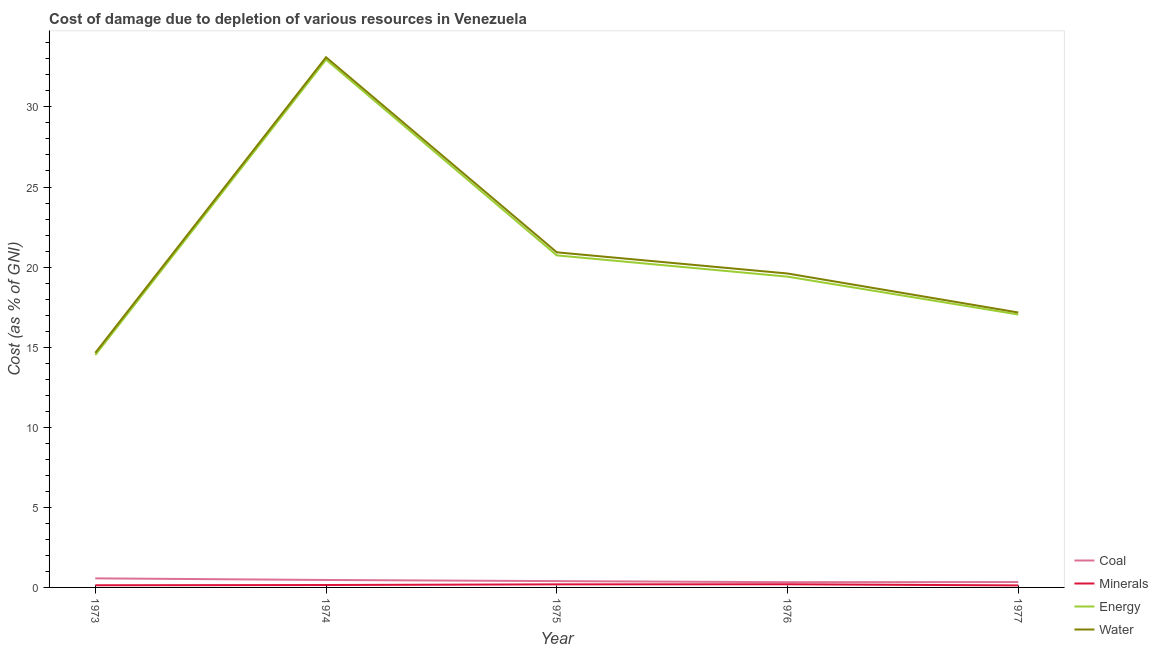Does the line corresponding to cost of damage due to depletion of minerals intersect with the line corresponding to cost of damage due to depletion of water?
Your answer should be compact. No. Is the number of lines equal to the number of legend labels?
Give a very brief answer. Yes. What is the cost of damage due to depletion of minerals in 1977?
Your response must be concise. 0.13. Across all years, what is the maximum cost of damage due to depletion of minerals?
Your response must be concise. 0.2. Across all years, what is the minimum cost of damage due to depletion of minerals?
Provide a succinct answer. 0.13. In which year was the cost of damage due to depletion of coal maximum?
Offer a terse response. 1973. What is the total cost of damage due to depletion of coal in the graph?
Ensure brevity in your answer.  2.09. What is the difference between the cost of damage due to depletion of energy in 1973 and that in 1977?
Your answer should be very brief. -2.53. What is the difference between the cost of damage due to depletion of minerals in 1973 and the cost of damage due to depletion of energy in 1974?
Provide a short and direct response. -32.82. What is the average cost of damage due to depletion of coal per year?
Offer a terse response. 0.42. In the year 1974, what is the difference between the cost of damage due to depletion of energy and cost of damage due to depletion of water?
Keep it short and to the point. -0.15. In how many years, is the cost of damage due to depletion of water greater than 26 %?
Your answer should be very brief. 1. What is the ratio of the cost of damage due to depletion of minerals in 1976 to that in 1977?
Keep it short and to the point. 1.56. Is the cost of damage due to depletion of energy in 1974 less than that in 1976?
Your answer should be compact. No. Is the difference between the cost of damage due to depletion of coal in 1974 and 1977 greater than the difference between the cost of damage due to depletion of minerals in 1974 and 1977?
Make the answer very short. Yes. What is the difference between the highest and the second highest cost of damage due to depletion of water?
Give a very brief answer. 12.18. What is the difference between the highest and the lowest cost of damage due to depletion of water?
Keep it short and to the point. 18.46. Is the sum of the cost of damage due to depletion of energy in 1974 and 1976 greater than the maximum cost of damage due to depletion of coal across all years?
Keep it short and to the point. Yes. Is it the case that in every year, the sum of the cost of damage due to depletion of energy and cost of damage due to depletion of minerals is greater than the sum of cost of damage due to depletion of water and cost of damage due to depletion of coal?
Provide a succinct answer. Yes. Is it the case that in every year, the sum of the cost of damage due to depletion of coal and cost of damage due to depletion of minerals is greater than the cost of damage due to depletion of energy?
Keep it short and to the point. No. Does the cost of damage due to depletion of water monotonically increase over the years?
Offer a very short reply. No. Is the cost of damage due to depletion of minerals strictly less than the cost of damage due to depletion of water over the years?
Provide a short and direct response. Yes. How many lines are there?
Keep it short and to the point. 4. Does the graph contain grids?
Provide a short and direct response. No. How many legend labels are there?
Give a very brief answer. 4. How are the legend labels stacked?
Your answer should be compact. Vertical. What is the title of the graph?
Give a very brief answer. Cost of damage due to depletion of various resources in Venezuela . What is the label or title of the X-axis?
Your answer should be very brief. Year. What is the label or title of the Y-axis?
Give a very brief answer. Cost (as % of GNI). What is the Cost (as % of GNI) of Coal in 1973?
Offer a terse response. 0.57. What is the Cost (as % of GNI) in Minerals in 1973?
Provide a succinct answer. 0.14. What is the Cost (as % of GNI) in Energy in 1973?
Provide a short and direct response. 14.51. What is the Cost (as % of GNI) of Water in 1973?
Provide a succinct answer. 14.65. What is the Cost (as % of GNI) of Coal in 1974?
Keep it short and to the point. 0.47. What is the Cost (as % of GNI) in Minerals in 1974?
Your answer should be very brief. 0.15. What is the Cost (as % of GNI) of Energy in 1974?
Your answer should be very brief. 32.95. What is the Cost (as % of GNI) in Water in 1974?
Keep it short and to the point. 33.1. What is the Cost (as % of GNI) of Coal in 1975?
Provide a succinct answer. 0.39. What is the Cost (as % of GNI) in Minerals in 1975?
Provide a succinct answer. 0.19. What is the Cost (as % of GNI) in Energy in 1975?
Make the answer very short. 20.73. What is the Cost (as % of GNI) of Water in 1975?
Ensure brevity in your answer.  20.92. What is the Cost (as % of GNI) in Coal in 1976?
Your response must be concise. 0.33. What is the Cost (as % of GNI) in Minerals in 1976?
Provide a succinct answer. 0.2. What is the Cost (as % of GNI) of Energy in 1976?
Give a very brief answer. 19.4. What is the Cost (as % of GNI) of Water in 1976?
Your response must be concise. 19.6. What is the Cost (as % of GNI) in Coal in 1977?
Provide a succinct answer. 0.34. What is the Cost (as % of GNI) of Minerals in 1977?
Ensure brevity in your answer.  0.13. What is the Cost (as % of GNI) in Energy in 1977?
Your response must be concise. 17.04. What is the Cost (as % of GNI) of Water in 1977?
Ensure brevity in your answer.  17.17. Across all years, what is the maximum Cost (as % of GNI) of Coal?
Your answer should be compact. 0.57. Across all years, what is the maximum Cost (as % of GNI) of Minerals?
Ensure brevity in your answer.  0.2. Across all years, what is the maximum Cost (as % of GNI) of Energy?
Your response must be concise. 32.95. Across all years, what is the maximum Cost (as % of GNI) of Water?
Keep it short and to the point. 33.1. Across all years, what is the minimum Cost (as % of GNI) of Coal?
Provide a succinct answer. 0.33. Across all years, what is the minimum Cost (as % of GNI) of Minerals?
Provide a short and direct response. 0.13. Across all years, what is the minimum Cost (as % of GNI) in Energy?
Offer a terse response. 14.51. Across all years, what is the minimum Cost (as % of GNI) of Water?
Ensure brevity in your answer.  14.65. What is the total Cost (as % of GNI) of Coal in the graph?
Your response must be concise. 2.09. What is the total Cost (as % of GNI) of Minerals in the graph?
Offer a very short reply. 0.8. What is the total Cost (as % of GNI) in Energy in the graph?
Your answer should be very brief. 104.63. What is the total Cost (as % of GNI) of Water in the graph?
Offer a terse response. 105.44. What is the difference between the Cost (as % of GNI) in Coal in 1973 and that in 1974?
Keep it short and to the point. 0.1. What is the difference between the Cost (as % of GNI) of Minerals in 1973 and that in 1974?
Offer a very short reply. -0.01. What is the difference between the Cost (as % of GNI) of Energy in 1973 and that in 1974?
Ensure brevity in your answer.  -18.44. What is the difference between the Cost (as % of GNI) in Water in 1973 and that in 1974?
Your answer should be compact. -18.46. What is the difference between the Cost (as % of GNI) of Coal in 1973 and that in 1975?
Your response must be concise. 0.17. What is the difference between the Cost (as % of GNI) in Minerals in 1973 and that in 1975?
Ensure brevity in your answer.  -0.06. What is the difference between the Cost (as % of GNI) in Energy in 1973 and that in 1975?
Make the answer very short. -6.22. What is the difference between the Cost (as % of GNI) of Water in 1973 and that in 1975?
Ensure brevity in your answer.  -6.28. What is the difference between the Cost (as % of GNI) in Coal in 1973 and that in 1976?
Ensure brevity in your answer.  0.24. What is the difference between the Cost (as % of GNI) of Minerals in 1973 and that in 1976?
Offer a very short reply. -0.06. What is the difference between the Cost (as % of GNI) in Energy in 1973 and that in 1976?
Your answer should be compact. -4.89. What is the difference between the Cost (as % of GNI) of Water in 1973 and that in 1976?
Your response must be concise. -4.95. What is the difference between the Cost (as % of GNI) in Coal in 1973 and that in 1977?
Provide a short and direct response. 0.23. What is the difference between the Cost (as % of GNI) in Minerals in 1973 and that in 1977?
Your answer should be compact. 0.01. What is the difference between the Cost (as % of GNI) in Energy in 1973 and that in 1977?
Provide a succinct answer. -2.53. What is the difference between the Cost (as % of GNI) of Water in 1973 and that in 1977?
Ensure brevity in your answer.  -2.52. What is the difference between the Cost (as % of GNI) in Coal in 1974 and that in 1975?
Make the answer very short. 0.07. What is the difference between the Cost (as % of GNI) in Minerals in 1974 and that in 1975?
Ensure brevity in your answer.  -0.04. What is the difference between the Cost (as % of GNI) in Energy in 1974 and that in 1975?
Give a very brief answer. 12.22. What is the difference between the Cost (as % of GNI) of Water in 1974 and that in 1975?
Provide a short and direct response. 12.18. What is the difference between the Cost (as % of GNI) in Coal in 1974 and that in 1976?
Provide a short and direct response. 0.14. What is the difference between the Cost (as % of GNI) in Minerals in 1974 and that in 1976?
Your response must be concise. -0.05. What is the difference between the Cost (as % of GNI) in Energy in 1974 and that in 1976?
Give a very brief answer. 13.55. What is the difference between the Cost (as % of GNI) of Water in 1974 and that in 1976?
Your response must be concise. 13.5. What is the difference between the Cost (as % of GNI) in Coal in 1974 and that in 1977?
Ensure brevity in your answer.  0.13. What is the difference between the Cost (as % of GNI) of Minerals in 1974 and that in 1977?
Offer a terse response. 0.02. What is the difference between the Cost (as % of GNI) in Energy in 1974 and that in 1977?
Your answer should be compact. 15.91. What is the difference between the Cost (as % of GNI) in Water in 1974 and that in 1977?
Your answer should be compact. 15.94. What is the difference between the Cost (as % of GNI) in Coal in 1975 and that in 1976?
Provide a succinct answer. 0.07. What is the difference between the Cost (as % of GNI) in Minerals in 1975 and that in 1976?
Make the answer very short. -0.01. What is the difference between the Cost (as % of GNI) in Energy in 1975 and that in 1976?
Keep it short and to the point. 1.33. What is the difference between the Cost (as % of GNI) in Water in 1975 and that in 1976?
Your answer should be very brief. 1.32. What is the difference between the Cost (as % of GNI) of Coal in 1975 and that in 1977?
Make the answer very short. 0.06. What is the difference between the Cost (as % of GNI) in Minerals in 1975 and that in 1977?
Keep it short and to the point. 0.06. What is the difference between the Cost (as % of GNI) of Energy in 1975 and that in 1977?
Ensure brevity in your answer.  3.69. What is the difference between the Cost (as % of GNI) of Water in 1975 and that in 1977?
Your answer should be compact. 3.76. What is the difference between the Cost (as % of GNI) of Coal in 1976 and that in 1977?
Offer a terse response. -0.01. What is the difference between the Cost (as % of GNI) of Minerals in 1976 and that in 1977?
Provide a short and direct response. 0.07. What is the difference between the Cost (as % of GNI) in Energy in 1976 and that in 1977?
Provide a succinct answer. 2.36. What is the difference between the Cost (as % of GNI) of Water in 1976 and that in 1977?
Your answer should be very brief. 2.43. What is the difference between the Cost (as % of GNI) in Coal in 1973 and the Cost (as % of GNI) in Minerals in 1974?
Offer a very short reply. 0.42. What is the difference between the Cost (as % of GNI) in Coal in 1973 and the Cost (as % of GNI) in Energy in 1974?
Provide a short and direct response. -32.38. What is the difference between the Cost (as % of GNI) in Coal in 1973 and the Cost (as % of GNI) in Water in 1974?
Make the answer very short. -32.54. What is the difference between the Cost (as % of GNI) in Minerals in 1973 and the Cost (as % of GNI) in Energy in 1974?
Give a very brief answer. -32.82. What is the difference between the Cost (as % of GNI) of Minerals in 1973 and the Cost (as % of GNI) of Water in 1974?
Provide a succinct answer. -32.97. What is the difference between the Cost (as % of GNI) in Energy in 1973 and the Cost (as % of GNI) in Water in 1974?
Provide a short and direct response. -18.59. What is the difference between the Cost (as % of GNI) of Coal in 1973 and the Cost (as % of GNI) of Minerals in 1975?
Offer a very short reply. 0.38. What is the difference between the Cost (as % of GNI) in Coal in 1973 and the Cost (as % of GNI) in Energy in 1975?
Ensure brevity in your answer.  -20.16. What is the difference between the Cost (as % of GNI) of Coal in 1973 and the Cost (as % of GNI) of Water in 1975?
Give a very brief answer. -20.36. What is the difference between the Cost (as % of GNI) of Minerals in 1973 and the Cost (as % of GNI) of Energy in 1975?
Offer a terse response. -20.59. What is the difference between the Cost (as % of GNI) in Minerals in 1973 and the Cost (as % of GNI) in Water in 1975?
Give a very brief answer. -20.79. What is the difference between the Cost (as % of GNI) in Energy in 1973 and the Cost (as % of GNI) in Water in 1975?
Offer a very short reply. -6.41. What is the difference between the Cost (as % of GNI) in Coal in 1973 and the Cost (as % of GNI) in Minerals in 1976?
Give a very brief answer. 0.37. What is the difference between the Cost (as % of GNI) of Coal in 1973 and the Cost (as % of GNI) of Energy in 1976?
Provide a short and direct response. -18.84. What is the difference between the Cost (as % of GNI) of Coal in 1973 and the Cost (as % of GNI) of Water in 1976?
Offer a terse response. -19.03. What is the difference between the Cost (as % of GNI) of Minerals in 1973 and the Cost (as % of GNI) of Energy in 1976?
Your response must be concise. -19.27. What is the difference between the Cost (as % of GNI) of Minerals in 1973 and the Cost (as % of GNI) of Water in 1976?
Keep it short and to the point. -19.46. What is the difference between the Cost (as % of GNI) in Energy in 1973 and the Cost (as % of GNI) in Water in 1976?
Ensure brevity in your answer.  -5.09. What is the difference between the Cost (as % of GNI) of Coal in 1973 and the Cost (as % of GNI) of Minerals in 1977?
Your answer should be very brief. 0.44. What is the difference between the Cost (as % of GNI) in Coal in 1973 and the Cost (as % of GNI) in Energy in 1977?
Your answer should be compact. -16.47. What is the difference between the Cost (as % of GNI) in Coal in 1973 and the Cost (as % of GNI) in Water in 1977?
Make the answer very short. -16.6. What is the difference between the Cost (as % of GNI) in Minerals in 1973 and the Cost (as % of GNI) in Energy in 1977?
Offer a terse response. -16.9. What is the difference between the Cost (as % of GNI) of Minerals in 1973 and the Cost (as % of GNI) of Water in 1977?
Make the answer very short. -17.03. What is the difference between the Cost (as % of GNI) of Energy in 1973 and the Cost (as % of GNI) of Water in 1977?
Your response must be concise. -2.66. What is the difference between the Cost (as % of GNI) in Coal in 1974 and the Cost (as % of GNI) in Minerals in 1975?
Offer a very short reply. 0.27. What is the difference between the Cost (as % of GNI) of Coal in 1974 and the Cost (as % of GNI) of Energy in 1975?
Provide a succinct answer. -20.27. What is the difference between the Cost (as % of GNI) in Coal in 1974 and the Cost (as % of GNI) in Water in 1975?
Provide a succinct answer. -20.46. What is the difference between the Cost (as % of GNI) in Minerals in 1974 and the Cost (as % of GNI) in Energy in 1975?
Your answer should be compact. -20.58. What is the difference between the Cost (as % of GNI) in Minerals in 1974 and the Cost (as % of GNI) in Water in 1975?
Provide a succinct answer. -20.77. What is the difference between the Cost (as % of GNI) of Energy in 1974 and the Cost (as % of GNI) of Water in 1975?
Ensure brevity in your answer.  12.03. What is the difference between the Cost (as % of GNI) in Coal in 1974 and the Cost (as % of GNI) in Minerals in 1976?
Your response must be concise. 0.27. What is the difference between the Cost (as % of GNI) in Coal in 1974 and the Cost (as % of GNI) in Energy in 1976?
Your answer should be compact. -18.94. What is the difference between the Cost (as % of GNI) in Coal in 1974 and the Cost (as % of GNI) in Water in 1976?
Make the answer very short. -19.13. What is the difference between the Cost (as % of GNI) of Minerals in 1974 and the Cost (as % of GNI) of Energy in 1976?
Your response must be concise. -19.25. What is the difference between the Cost (as % of GNI) of Minerals in 1974 and the Cost (as % of GNI) of Water in 1976?
Offer a terse response. -19.45. What is the difference between the Cost (as % of GNI) of Energy in 1974 and the Cost (as % of GNI) of Water in 1976?
Offer a terse response. 13.35. What is the difference between the Cost (as % of GNI) in Coal in 1974 and the Cost (as % of GNI) in Minerals in 1977?
Give a very brief answer. 0.34. What is the difference between the Cost (as % of GNI) of Coal in 1974 and the Cost (as % of GNI) of Energy in 1977?
Ensure brevity in your answer.  -16.57. What is the difference between the Cost (as % of GNI) in Coal in 1974 and the Cost (as % of GNI) in Water in 1977?
Make the answer very short. -16.7. What is the difference between the Cost (as % of GNI) of Minerals in 1974 and the Cost (as % of GNI) of Energy in 1977?
Your answer should be compact. -16.89. What is the difference between the Cost (as % of GNI) of Minerals in 1974 and the Cost (as % of GNI) of Water in 1977?
Provide a short and direct response. -17.01. What is the difference between the Cost (as % of GNI) in Energy in 1974 and the Cost (as % of GNI) in Water in 1977?
Your answer should be very brief. 15.79. What is the difference between the Cost (as % of GNI) of Coal in 1975 and the Cost (as % of GNI) of Minerals in 1976?
Give a very brief answer. 0.2. What is the difference between the Cost (as % of GNI) in Coal in 1975 and the Cost (as % of GNI) in Energy in 1976?
Offer a very short reply. -19.01. What is the difference between the Cost (as % of GNI) in Coal in 1975 and the Cost (as % of GNI) in Water in 1976?
Provide a succinct answer. -19.21. What is the difference between the Cost (as % of GNI) of Minerals in 1975 and the Cost (as % of GNI) of Energy in 1976?
Keep it short and to the point. -19.21. What is the difference between the Cost (as % of GNI) in Minerals in 1975 and the Cost (as % of GNI) in Water in 1976?
Your answer should be very brief. -19.41. What is the difference between the Cost (as % of GNI) of Energy in 1975 and the Cost (as % of GNI) of Water in 1976?
Offer a very short reply. 1.13. What is the difference between the Cost (as % of GNI) of Coal in 1975 and the Cost (as % of GNI) of Minerals in 1977?
Make the answer very short. 0.27. What is the difference between the Cost (as % of GNI) in Coal in 1975 and the Cost (as % of GNI) in Energy in 1977?
Your answer should be compact. -16.64. What is the difference between the Cost (as % of GNI) of Coal in 1975 and the Cost (as % of GNI) of Water in 1977?
Ensure brevity in your answer.  -16.77. What is the difference between the Cost (as % of GNI) in Minerals in 1975 and the Cost (as % of GNI) in Energy in 1977?
Give a very brief answer. -16.85. What is the difference between the Cost (as % of GNI) in Minerals in 1975 and the Cost (as % of GNI) in Water in 1977?
Give a very brief answer. -16.97. What is the difference between the Cost (as % of GNI) of Energy in 1975 and the Cost (as % of GNI) of Water in 1977?
Provide a succinct answer. 3.57. What is the difference between the Cost (as % of GNI) in Coal in 1976 and the Cost (as % of GNI) in Minerals in 1977?
Make the answer very short. 0.2. What is the difference between the Cost (as % of GNI) of Coal in 1976 and the Cost (as % of GNI) of Energy in 1977?
Your answer should be very brief. -16.71. What is the difference between the Cost (as % of GNI) in Coal in 1976 and the Cost (as % of GNI) in Water in 1977?
Offer a very short reply. -16.84. What is the difference between the Cost (as % of GNI) in Minerals in 1976 and the Cost (as % of GNI) in Energy in 1977?
Give a very brief answer. -16.84. What is the difference between the Cost (as % of GNI) of Minerals in 1976 and the Cost (as % of GNI) of Water in 1977?
Your answer should be very brief. -16.97. What is the difference between the Cost (as % of GNI) of Energy in 1976 and the Cost (as % of GNI) of Water in 1977?
Give a very brief answer. 2.24. What is the average Cost (as % of GNI) of Coal per year?
Make the answer very short. 0.42. What is the average Cost (as % of GNI) in Minerals per year?
Provide a succinct answer. 0.16. What is the average Cost (as % of GNI) in Energy per year?
Your response must be concise. 20.93. What is the average Cost (as % of GNI) in Water per year?
Your answer should be compact. 21.09. In the year 1973, what is the difference between the Cost (as % of GNI) in Coal and Cost (as % of GNI) in Minerals?
Your response must be concise. 0.43. In the year 1973, what is the difference between the Cost (as % of GNI) of Coal and Cost (as % of GNI) of Energy?
Provide a succinct answer. -13.94. In the year 1973, what is the difference between the Cost (as % of GNI) of Coal and Cost (as % of GNI) of Water?
Offer a very short reply. -14.08. In the year 1973, what is the difference between the Cost (as % of GNI) in Minerals and Cost (as % of GNI) in Energy?
Provide a short and direct response. -14.37. In the year 1973, what is the difference between the Cost (as % of GNI) in Minerals and Cost (as % of GNI) in Water?
Make the answer very short. -14.51. In the year 1973, what is the difference between the Cost (as % of GNI) of Energy and Cost (as % of GNI) of Water?
Your answer should be very brief. -0.14. In the year 1974, what is the difference between the Cost (as % of GNI) of Coal and Cost (as % of GNI) of Minerals?
Offer a very short reply. 0.31. In the year 1974, what is the difference between the Cost (as % of GNI) in Coal and Cost (as % of GNI) in Energy?
Keep it short and to the point. -32.49. In the year 1974, what is the difference between the Cost (as % of GNI) of Coal and Cost (as % of GNI) of Water?
Your answer should be compact. -32.64. In the year 1974, what is the difference between the Cost (as % of GNI) in Minerals and Cost (as % of GNI) in Energy?
Provide a succinct answer. -32.8. In the year 1974, what is the difference between the Cost (as % of GNI) of Minerals and Cost (as % of GNI) of Water?
Provide a succinct answer. -32.95. In the year 1974, what is the difference between the Cost (as % of GNI) of Energy and Cost (as % of GNI) of Water?
Make the answer very short. -0.15. In the year 1975, what is the difference between the Cost (as % of GNI) of Coal and Cost (as % of GNI) of Minerals?
Your response must be concise. 0.2. In the year 1975, what is the difference between the Cost (as % of GNI) of Coal and Cost (as % of GNI) of Energy?
Give a very brief answer. -20.34. In the year 1975, what is the difference between the Cost (as % of GNI) of Coal and Cost (as % of GNI) of Water?
Your response must be concise. -20.53. In the year 1975, what is the difference between the Cost (as % of GNI) in Minerals and Cost (as % of GNI) in Energy?
Your response must be concise. -20.54. In the year 1975, what is the difference between the Cost (as % of GNI) of Minerals and Cost (as % of GNI) of Water?
Keep it short and to the point. -20.73. In the year 1975, what is the difference between the Cost (as % of GNI) in Energy and Cost (as % of GNI) in Water?
Ensure brevity in your answer.  -0.19. In the year 1976, what is the difference between the Cost (as % of GNI) in Coal and Cost (as % of GNI) in Minerals?
Make the answer very short. 0.13. In the year 1976, what is the difference between the Cost (as % of GNI) in Coal and Cost (as % of GNI) in Energy?
Your answer should be compact. -19.08. In the year 1976, what is the difference between the Cost (as % of GNI) of Coal and Cost (as % of GNI) of Water?
Provide a succinct answer. -19.27. In the year 1976, what is the difference between the Cost (as % of GNI) of Minerals and Cost (as % of GNI) of Energy?
Give a very brief answer. -19.21. In the year 1976, what is the difference between the Cost (as % of GNI) of Minerals and Cost (as % of GNI) of Water?
Offer a very short reply. -19.4. In the year 1976, what is the difference between the Cost (as % of GNI) of Energy and Cost (as % of GNI) of Water?
Offer a terse response. -0.2. In the year 1977, what is the difference between the Cost (as % of GNI) of Coal and Cost (as % of GNI) of Minerals?
Keep it short and to the point. 0.21. In the year 1977, what is the difference between the Cost (as % of GNI) of Coal and Cost (as % of GNI) of Energy?
Offer a terse response. -16.7. In the year 1977, what is the difference between the Cost (as % of GNI) in Coal and Cost (as % of GNI) in Water?
Your answer should be very brief. -16.83. In the year 1977, what is the difference between the Cost (as % of GNI) in Minerals and Cost (as % of GNI) in Energy?
Provide a short and direct response. -16.91. In the year 1977, what is the difference between the Cost (as % of GNI) of Minerals and Cost (as % of GNI) of Water?
Give a very brief answer. -17.04. In the year 1977, what is the difference between the Cost (as % of GNI) in Energy and Cost (as % of GNI) in Water?
Make the answer very short. -0.13. What is the ratio of the Cost (as % of GNI) of Coal in 1973 to that in 1974?
Give a very brief answer. 1.22. What is the ratio of the Cost (as % of GNI) of Minerals in 1973 to that in 1974?
Offer a very short reply. 0.9. What is the ratio of the Cost (as % of GNI) of Energy in 1973 to that in 1974?
Provide a short and direct response. 0.44. What is the ratio of the Cost (as % of GNI) in Water in 1973 to that in 1974?
Ensure brevity in your answer.  0.44. What is the ratio of the Cost (as % of GNI) in Coal in 1973 to that in 1975?
Your response must be concise. 1.44. What is the ratio of the Cost (as % of GNI) in Minerals in 1973 to that in 1975?
Offer a terse response. 0.71. What is the ratio of the Cost (as % of GNI) in Energy in 1973 to that in 1975?
Offer a terse response. 0.7. What is the ratio of the Cost (as % of GNI) in Water in 1973 to that in 1975?
Provide a short and direct response. 0.7. What is the ratio of the Cost (as % of GNI) in Coal in 1973 to that in 1976?
Your response must be concise. 1.73. What is the ratio of the Cost (as % of GNI) of Minerals in 1973 to that in 1976?
Make the answer very short. 0.69. What is the ratio of the Cost (as % of GNI) of Energy in 1973 to that in 1976?
Your response must be concise. 0.75. What is the ratio of the Cost (as % of GNI) of Water in 1973 to that in 1976?
Ensure brevity in your answer.  0.75. What is the ratio of the Cost (as % of GNI) in Coal in 1973 to that in 1977?
Keep it short and to the point. 1.69. What is the ratio of the Cost (as % of GNI) of Minerals in 1973 to that in 1977?
Your response must be concise. 1.07. What is the ratio of the Cost (as % of GNI) in Energy in 1973 to that in 1977?
Provide a succinct answer. 0.85. What is the ratio of the Cost (as % of GNI) of Water in 1973 to that in 1977?
Offer a very short reply. 0.85. What is the ratio of the Cost (as % of GNI) in Coal in 1974 to that in 1975?
Your answer should be compact. 1.18. What is the ratio of the Cost (as % of GNI) in Minerals in 1974 to that in 1975?
Make the answer very short. 0.79. What is the ratio of the Cost (as % of GNI) of Energy in 1974 to that in 1975?
Ensure brevity in your answer.  1.59. What is the ratio of the Cost (as % of GNI) of Water in 1974 to that in 1975?
Your answer should be very brief. 1.58. What is the ratio of the Cost (as % of GNI) in Coal in 1974 to that in 1976?
Your answer should be very brief. 1.42. What is the ratio of the Cost (as % of GNI) of Minerals in 1974 to that in 1976?
Ensure brevity in your answer.  0.77. What is the ratio of the Cost (as % of GNI) in Energy in 1974 to that in 1976?
Your answer should be compact. 1.7. What is the ratio of the Cost (as % of GNI) in Water in 1974 to that in 1976?
Give a very brief answer. 1.69. What is the ratio of the Cost (as % of GNI) of Coal in 1974 to that in 1977?
Provide a succinct answer. 1.39. What is the ratio of the Cost (as % of GNI) in Minerals in 1974 to that in 1977?
Give a very brief answer. 1.19. What is the ratio of the Cost (as % of GNI) of Energy in 1974 to that in 1977?
Give a very brief answer. 1.93. What is the ratio of the Cost (as % of GNI) of Water in 1974 to that in 1977?
Give a very brief answer. 1.93. What is the ratio of the Cost (as % of GNI) of Coal in 1975 to that in 1976?
Your answer should be compact. 1.21. What is the ratio of the Cost (as % of GNI) of Minerals in 1975 to that in 1976?
Make the answer very short. 0.97. What is the ratio of the Cost (as % of GNI) of Energy in 1975 to that in 1976?
Provide a short and direct response. 1.07. What is the ratio of the Cost (as % of GNI) in Water in 1975 to that in 1976?
Make the answer very short. 1.07. What is the ratio of the Cost (as % of GNI) of Coal in 1975 to that in 1977?
Keep it short and to the point. 1.18. What is the ratio of the Cost (as % of GNI) of Minerals in 1975 to that in 1977?
Make the answer very short. 1.51. What is the ratio of the Cost (as % of GNI) in Energy in 1975 to that in 1977?
Provide a succinct answer. 1.22. What is the ratio of the Cost (as % of GNI) in Water in 1975 to that in 1977?
Your answer should be compact. 1.22. What is the ratio of the Cost (as % of GNI) of Coal in 1976 to that in 1977?
Your answer should be compact. 0.97. What is the ratio of the Cost (as % of GNI) in Minerals in 1976 to that in 1977?
Offer a terse response. 1.56. What is the ratio of the Cost (as % of GNI) in Energy in 1976 to that in 1977?
Give a very brief answer. 1.14. What is the ratio of the Cost (as % of GNI) in Water in 1976 to that in 1977?
Your response must be concise. 1.14. What is the difference between the highest and the second highest Cost (as % of GNI) of Coal?
Give a very brief answer. 0.1. What is the difference between the highest and the second highest Cost (as % of GNI) of Minerals?
Keep it short and to the point. 0.01. What is the difference between the highest and the second highest Cost (as % of GNI) of Energy?
Provide a short and direct response. 12.22. What is the difference between the highest and the second highest Cost (as % of GNI) of Water?
Provide a short and direct response. 12.18. What is the difference between the highest and the lowest Cost (as % of GNI) of Coal?
Your answer should be very brief. 0.24. What is the difference between the highest and the lowest Cost (as % of GNI) of Minerals?
Make the answer very short. 0.07. What is the difference between the highest and the lowest Cost (as % of GNI) of Energy?
Ensure brevity in your answer.  18.44. What is the difference between the highest and the lowest Cost (as % of GNI) in Water?
Your answer should be compact. 18.46. 